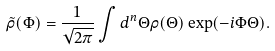<formula> <loc_0><loc_0><loc_500><loc_500>\tilde { \rho } ( { \Phi } ) = \frac { 1 } { \sqrt { 2 \pi } } \int d ^ { n } { \Theta } \rho ( { \Theta } ) \exp ( - i { \Phi } { \Theta } ) .</formula> 